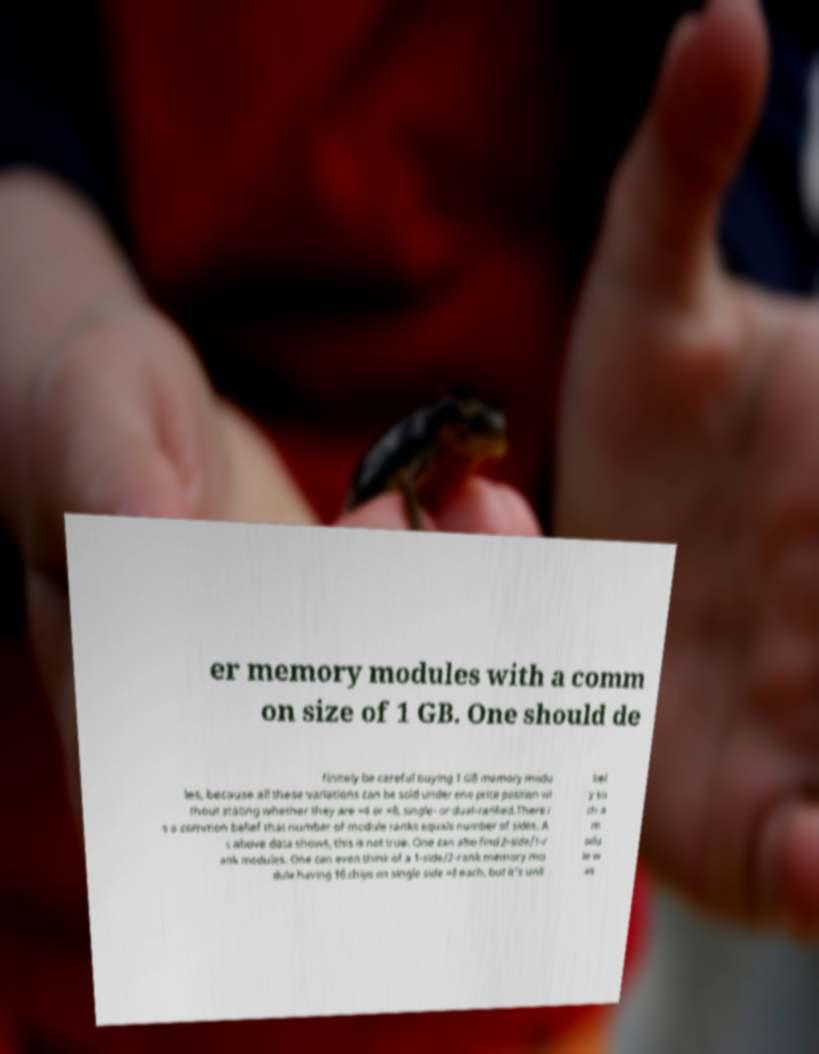Could you assist in decoding the text presented in this image and type it out clearly? er memory modules with a comm on size of 1 GB. One should de finitely be careful buying 1 GB memory modu les, because all these variations can be sold under one price position wi thout stating whether they are ×4 or ×8, single- or dual-ranked.There i s a common belief that number of module ranks equals number of sides. A s above data shows, this is not true. One can also find 2-side/1-r ank modules. One can even think of a 1-side/2-rank memory mo dule having 16 chips on single side ×8 each, but it's unli kel y su ch a m odu le w as 